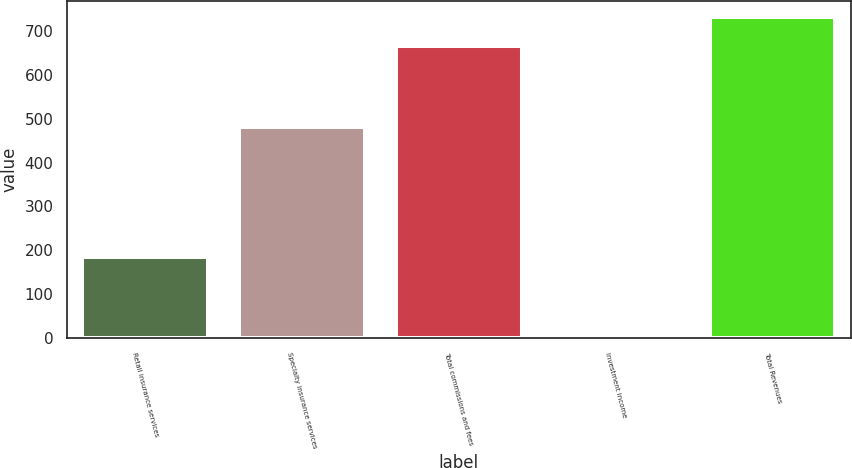Convert chart to OTSL. <chart><loc_0><loc_0><loc_500><loc_500><bar_chart><fcel>Retail insurance services<fcel>Specialty insurance services<fcel>Total commissions and fees<fcel>Investment income<fcel>Total Revenues<nl><fcel>185<fcel>480<fcel>665<fcel>1<fcel>731.5<nl></chart> 